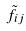Convert formula to latex. <formula><loc_0><loc_0><loc_500><loc_500>\tilde { f } _ { i j }</formula> 